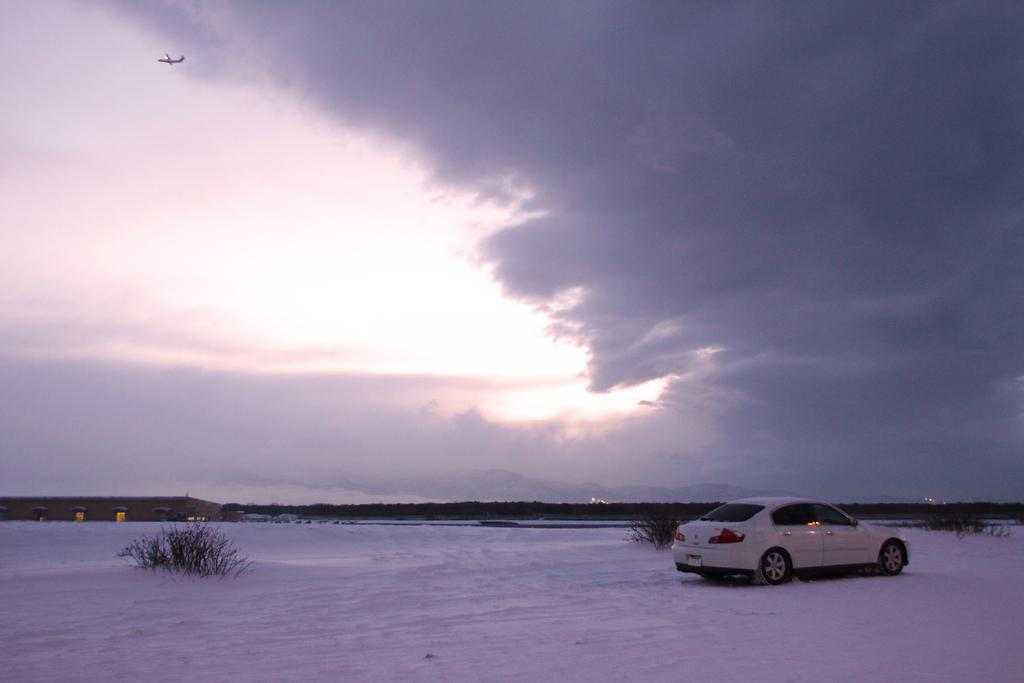What type of vehicle is on the right side of the image? There is a car on the right side of the image. What type of building is on the left side of the image? There is a house on the left side of the image. What type of weather is depicted in the image? There is snow at the bottom side of the image, indicating a snowy or wintry scene. Can you tell me how many crows are sitting on the car in the image? There are no crows present in the image; it only features a car and a house in a snowy setting. 